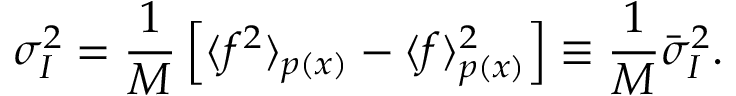Convert formula to latex. <formula><loc_0><loc_0><loc_500><loc_500>\sigma _ { I } ^ { 2 } = \frac { 1 } { M } \left [ \langle f ^ { 2 } \rangle _ { p ( x ) } - \langle f \rangle _ { p ( x ) } ^ { 2 } \right ] \equiv \frac { 1 } { M } \bar { \sigma } _ { I } ^ { 2 } .</formula> 